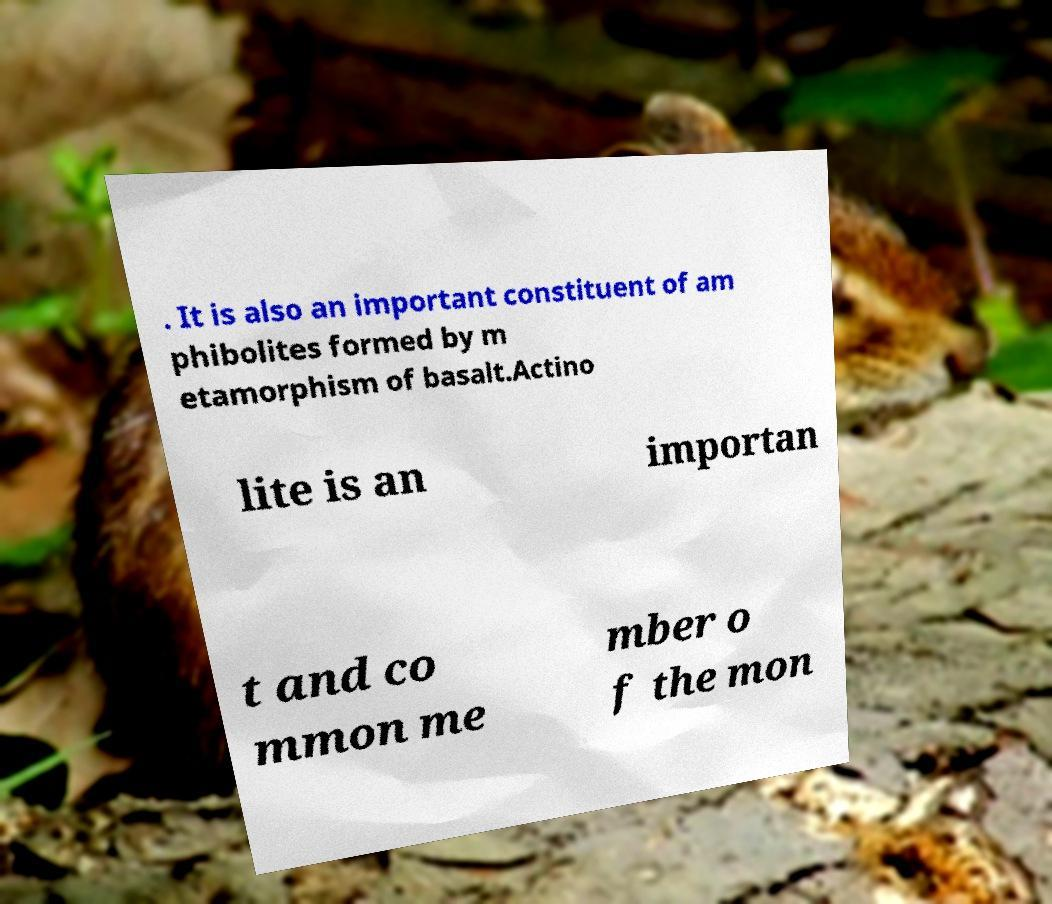Please identify and transcribe the text found in this image. . It is also an important constituent of am phibolites formed by m etamorphism of basalt.Actino lite is an importan t and co mmon me mber o f the mon 